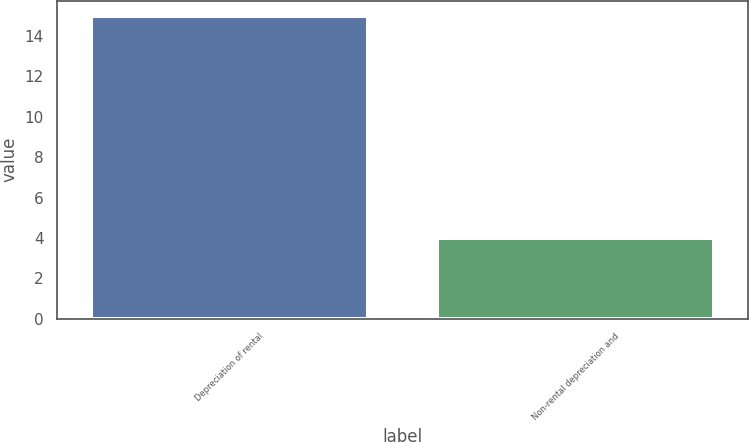Convert chart to OTSL. <chart><loc_0><loc_0><loc_500><loc_500><bar_chart><fcel>Depreciation of rental<fcel>Non-rental depreciation and<nl><fcel>15<fcel>4<nl></chart> 